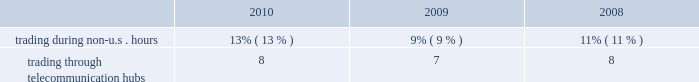Kendal vroman , 39 mr .
Vroman has served as our managing director , commodity products , otc services & information products since february 2010 .
Mr .
Vroman previously served as managing director and chief corporate development officer from 2008 to 2010 .
Mr .
Vroman joined us in 2001 and since then has held positions of increasing responsibility , including most recently as managing director , corporate development and managing director , information and technology services .
Scot e .
Warren , 47 mr .
Warren has served as our managing director , equity index products and index services since february 2010 .
Mr .
Warren previously served as our managing director , equity products since joining us in 2007 .
Prior to that , mr .
Warren worked for goldman sachs as its president , manager trading and business analysis team .
Prior to goldman sachs , mr .
Warren managed equity and option execution and clearing businesses for abn amro in chicago and was a senior consultant for arthur andersen & co .
For financial services firms .
Financial information about geographic areas due to the nature of its business , cme group does not track revenues based upon geographic location .
We do , however , track trading volume generated outside of traditional u.s .
Trading hours and through our international telecommunication hubs .
Our customers can directly access our exchanges throughout the world .
The table shows the percentage of our total trading volume on our globex electronic trading platform generated during non-u.s .
Hours and through our international hubs. .
Available information our web site is www.cmegroup.com .
Information made available on our web site does not constitute part of this document .
We make available on our web site our annual reports on form 10-k , quarterly reports on form 10-q , current reports on form 8-k and amendments to those reports as soon as reasonably practicable after we electronically file or furnish such materials to the sec .
Our corporate governance materials , including our corporate governance principles , director conflict of interest policy , board of directors code of ethics , categorical independence standards , employee code of conduct and the charters for all the standing committees of our board , may also be found on our web site .
Copies of these materials are also available to shareholders free of charge upon written request to shareholder relations and member services , attention ms .
Beth hausoul , cme group inc. , 20 south wacker drive , chicago , illinois 60606. .
What was the average percent of trading through telecommunication hubs for 2008-2010 ? \\n? 
Computations: table_average(trading through telecommunication hubs, none)
Answer: 7.66667. 